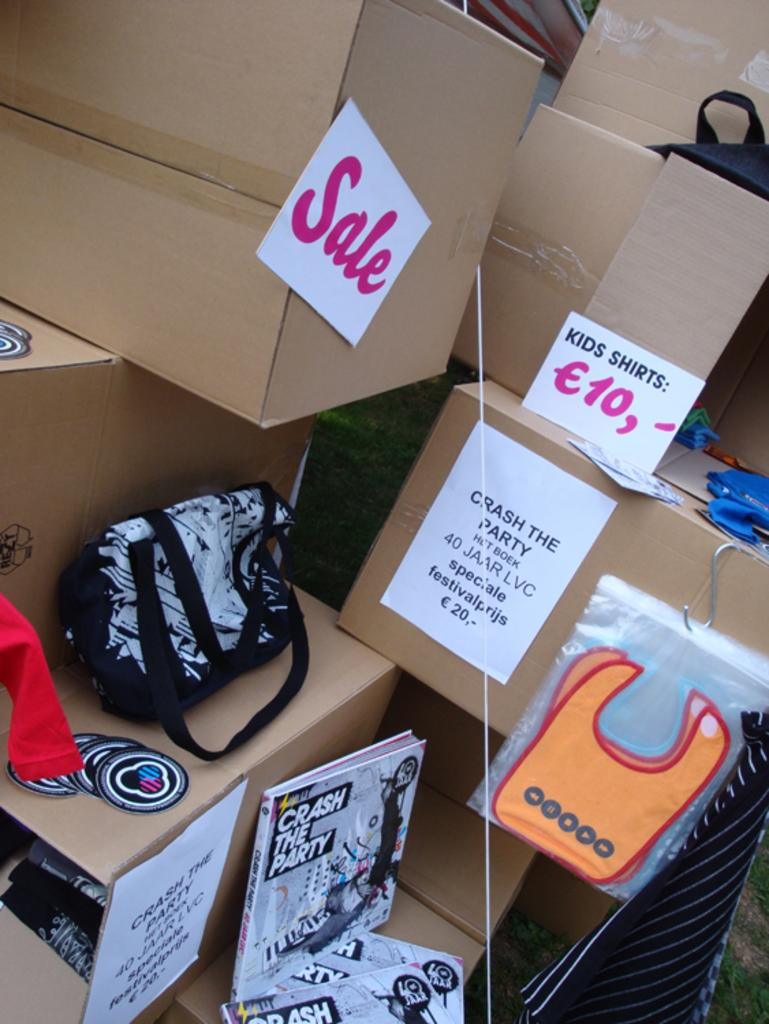<image>
Offer a succinct explanation of the picture presented. A number of cardboard boxes, one of which is advertising Kids Shirts for ten Euros 